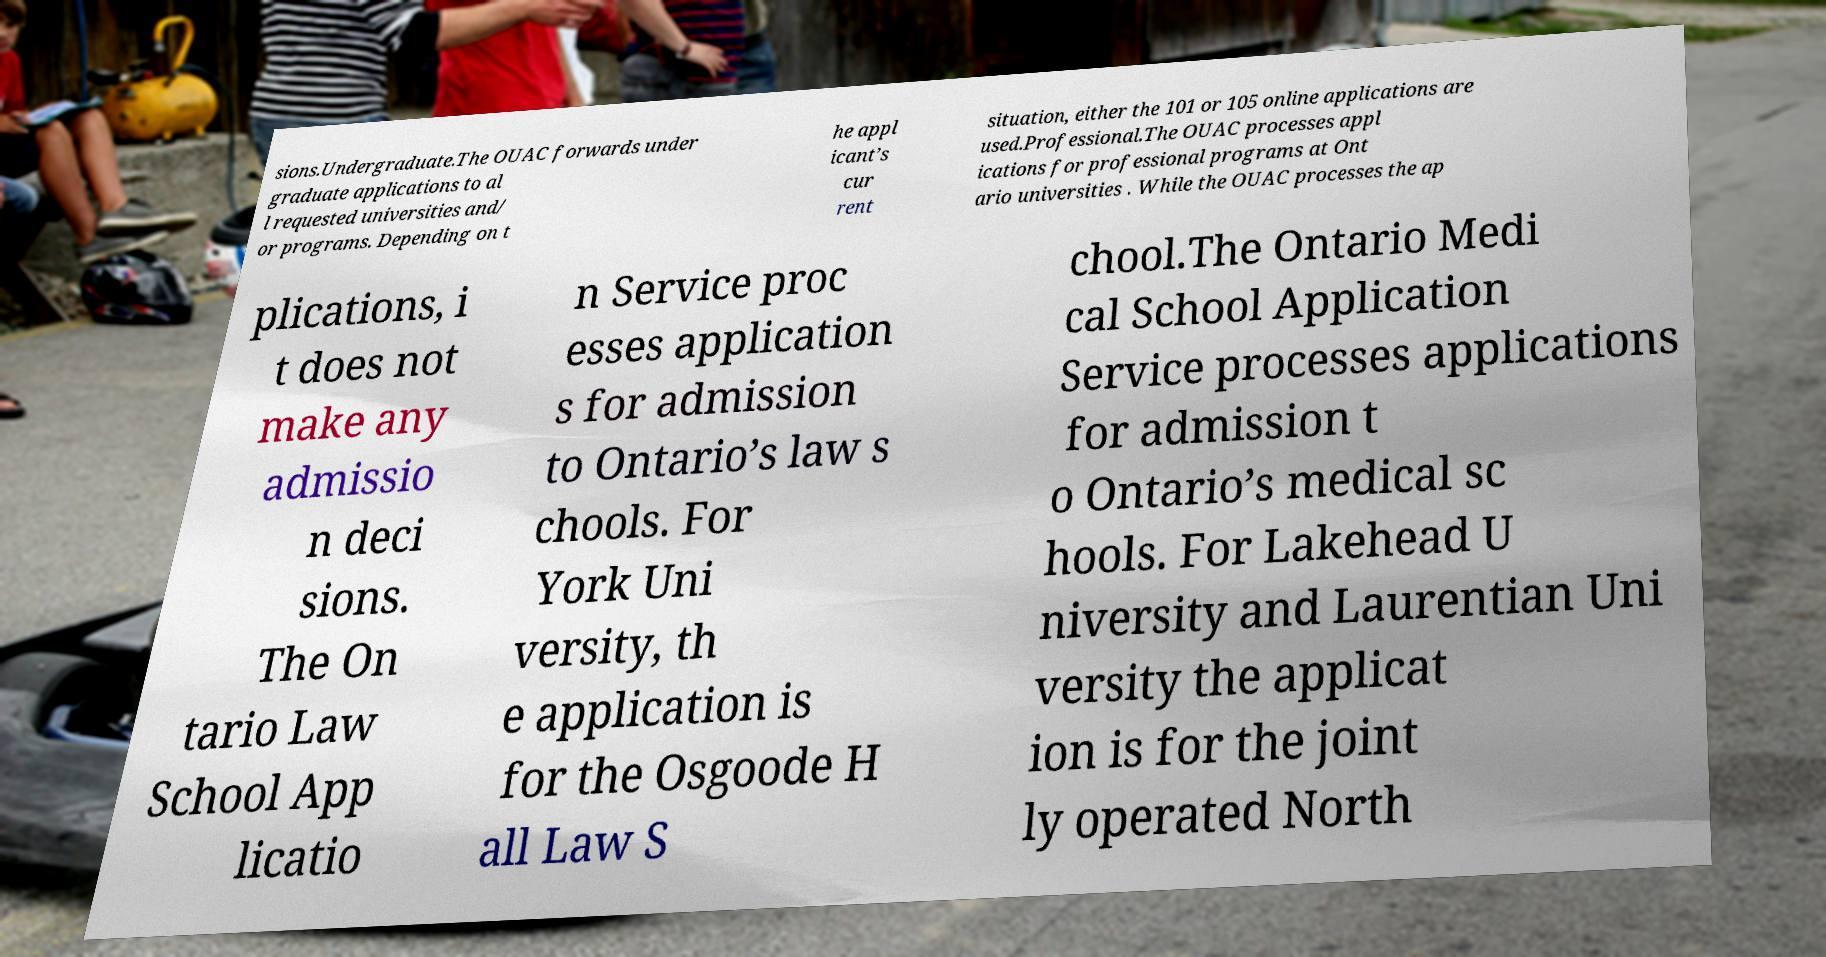What messages or text are displayed in this image? I need them in a readable, typed format. sions.Undergraduate.The OUAC forwards under graduate applications to al l requested universities and/ or programs. Depending on t he appl icant’s cur rent situation, either the 101 or 105 online applications are used.Professional.The OUAC processes appl ications for professional programs at Ont ario universities . While the OUAC processes the ap plications, i t does not make any admissio n deci sions. The On tario Law School App licatio n Service proc esses application s for admission to Ontario’s law s chools. For York Uni versity, th e application is for the Osgoode H all Law S chool.The Ontario Medi cal School Application Service processes applications for admission t o Ontario’s medical sc hools. For Lakehead U niversity and Laurentian Uni versity the applicat ion is for the joint ly operated North 